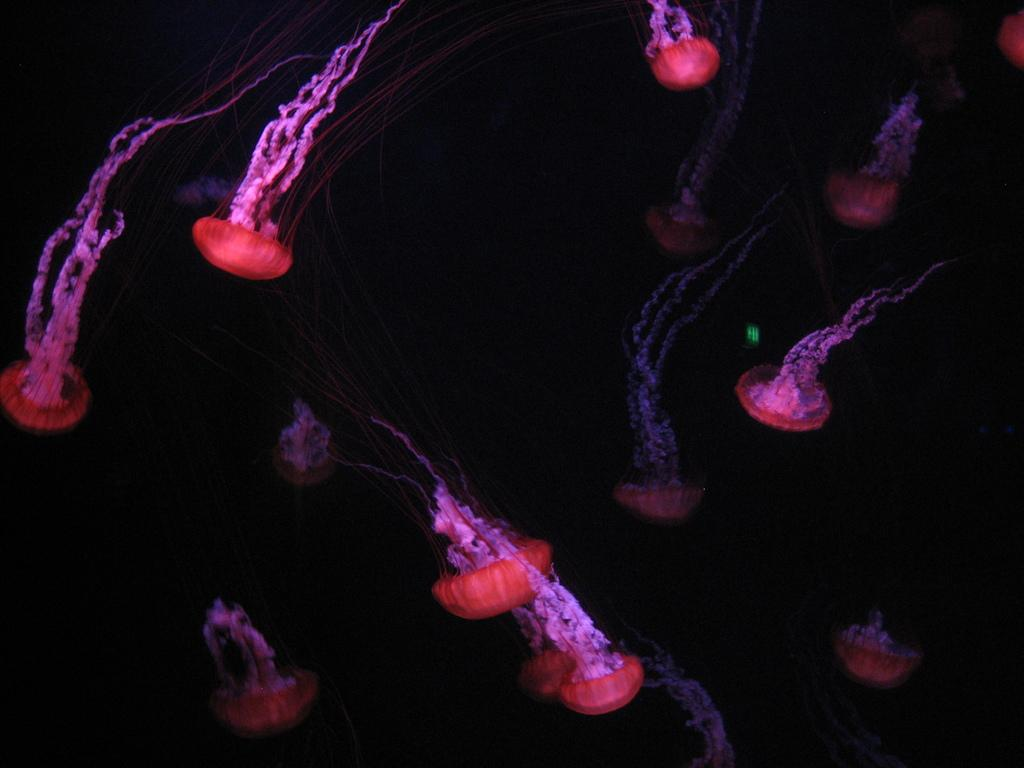What type of sea creatures are present in the image? There are jellyfishes in the image. Can you describe the setting of the image? The image is set in a dark environment. Are there any dolls visible in the image? No, there are no dolls present in the image. 